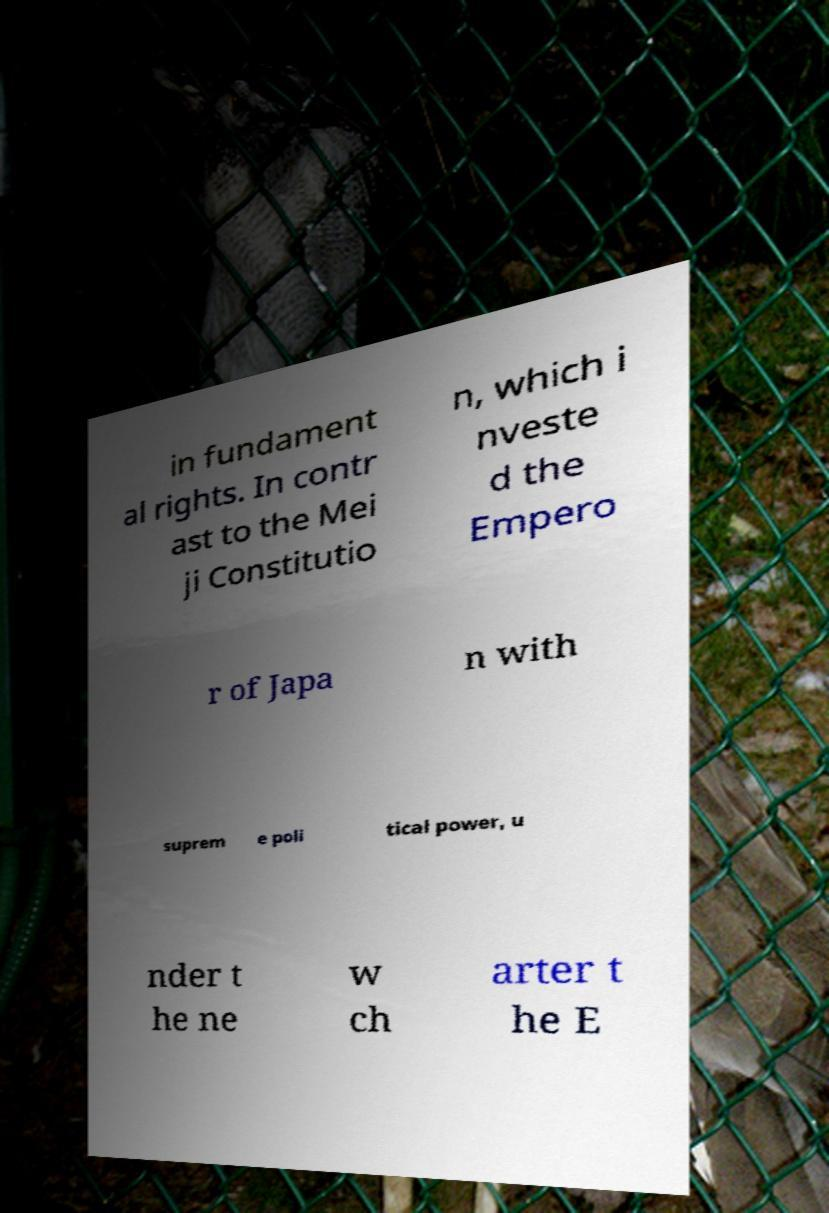Please identify and transcribe the text found in this image. in fundament al rights. In contr ast to the Mei ji Constitutio n, which i nveste d the Empero r of Japa n with suprem e poli tical power, u nder t he ne w ch arter t he E 